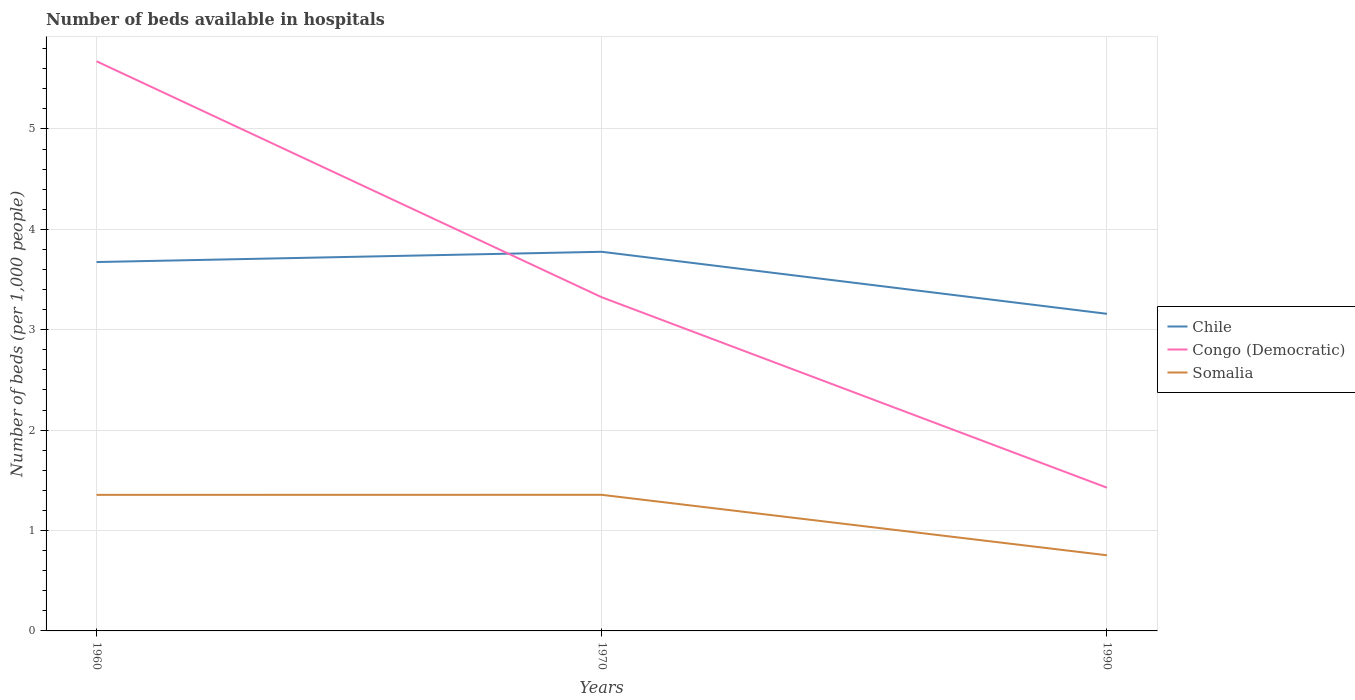How many different coloured lines are there?
Offer a terse response. 3. Is the number of lines equal to the number of legend labels?
Your response must be concise. Yes. Across all years, what is the maximum number of beds in the hospiatls of in Somalia?
Offer a terse response. 0.75. What is the total number of beds in the hospiatls of in Somalia in the graph?
Provide a succinct answer. 0.6. What is the difference between the highest and the second highest number of beds in the hospiatls of in Congo (Democratic)?
Your answer should be very brief. 4.25. Is the number of beds in the hospiatls of in Somalia strictly greater than the number of beds in the hospiatls of in Congo (Democratic) over the years?
Offer a terse response. Yes. Does the graph contain grids?
Offer a terse response. Yes. How many legend labels are there?
Give a very brief answer. 3. What is the title of the graph?
Offer a terse response. Number of beds available in hospitals. Does "South Asia" appear as one of the legend labels in the graph?
Make the answer very short. No. What is the label or title of the X-axis?
Keep it short and to the point. Years. What is the label or title of the Y-axis?
Your answer should be compact. Number of beds (per 1,0 people). What is the Number of beds (per 1,000 people) of Chile in 1960?
Offer a terse response. 3.67. What is the Number of beds (per 1,000 people) of Congo (Democratic) in 1960?
Your answer should be compact. 5.67. What is the Number of beds (per 1,000 people) in Somalia in 1960?
Offer a terse response. 1.36. What is the Number of beds (per 1,000 people) in Chile in 1970?
Ensure brevity in your answer.  3.78. What is the Number of beds (per 1,000 people) of Congo (Democratic) in 1970?
Provide a short and direct response. 3.32. What is the Number of beds (per 1,000 people) of Somalia in 1970?
Your answer should be very brief. 1.36. What is the Number of beds (per 1,000 people) of Chile in 1990?
Your response must be concise. 3.16. What is the Number of beds (per 1,000 people) in Congo (Democratic) in 1990?
Your answer should be compact. 1.43. What is the Number of beds (per 1,000 people) in Somalia in 1990?
Ensure brevity in your answer.  0.75. Across all years, what is the maximum Number of beds (per 1,000 people) of Chile?
Give a very brief answer. 3.78. Across all years, what is the maximum Number of beds (per 1,000 people) in Congo (Democratic)?
Your answer should be compact. 5.67. Across all years, what is the maximum Number of beds (per 1,000 people) in Somalia?
Your response must be concise. 1.36. Across all years, what is the minimum Number of beds (per 1,000 people) in Chile?
Offer a very short reply. 3.16. Across all years, what is the minimum Number of beds (per 1,000 people) in Congo (Democratic)?
Your response must be concise. 1.43. Across all years, what is the minimum Number of beds (per 1,000 people) in Somalia?
Keep it short and to the point. 0.75. What is the total Number of beds (per 1,000 people) of Chile in the graph?
Your response must be concise. 10.61. What is the total Number of beds (per 1,000 people) in Congo (Democratic) in the graph?
Make the answer very short. 10.42. What is the total Number of beds (per 1,000 people) in Somalia in the graph?
Offer a very short reply. 3.46. What is the difference between the Number of beds (per 1,000 people) in Chile in 1960 and that in 1970?
Provide a short and direct response. -0.1. What is the difference between the Number of beds (per 1,000 people) in Congo (Democratic) in 1960 and that in 1970?
Make the answer very short. 2.35. What is the difference between the Number of beds (per 1,000 people) in Somalia in 1960 and that in 1970?
Your answer should be compact. -0. What is the difference between the Number of beds (per 1,000 people) of Chile in 1960 and that in 1990?
Your response must be concise. 0.52. What is the difference between the Number of beds (per 1,000 people) in Congo (Democratic) in 1960 and that in 1990?
Provide a short and direct response. 4.25. What is the difference between the Number of beds (per 1,000 people) of Somalia in 1960 and that in 1990?
Your response must be concise. 0.6. What is the difference between the Number of beds (per 1,000 people) in Chile in 1970 and that in 1990?
Provide a short and direct response. 0.62. What is the difference between the Number of beds (per 1,000 people) of Congo (Democratic) in 1970 and that in 1990?
Provide a succinct answer. 1.9. What is the difference between the Number of beds (per 1,000 people) in Somalia in 1970 and that in 1990?
Provide a short and direct response. 0.6. What is the difference between the Number of beds (per 1,000 people) in Chile in 1960 and the Number of beds (per 1,000 people) in Congo (Democratic) in 1970?
Provide a succinct answer. 0.35. What is the difference between the Number of beds (per 1,000 people) of Chile in 1960 and the Number of beds (per 1,000 people) of Somalia in 1970?
Keep it short and to the point. 2.32. What is the difference between the Number of beds (per 1,000 people) of Congo (Democratic) in 1960 and the Number of beds (per 1,000 people) of Somalia in 1970?
Offer a terse response. 4.32. What is the difference between the Number of beds (per 1,000 people) of Chile in 1960 and the Number of beds (per 1,000 people) of Congo (Democratic) in 1990?
Keep it short and to the point. 2.25. What is the difference between the Number of beds (per 1,000 people) of Chile in 1960 and the Number of beds (per 1,000 people) of Somalia in 1990?
Give a very brief answer. 2.92. What is the difference between the Number of beds (per 1,000 people) in Congo (Democratic) in 1960 and the Number of beds (per 1,000 people) in Somalia in 1990?
Keep it short and to the point. 4.92. What is the difference between the Number of beds (per 1,000 people) in Chile in 1970 and the Number of beds (per 1,000 people) in Congo (Democratic) in 1990?
Provide a short and direct response. 2.35. What is the difference between the Number of beds (per 1,000 people) of Chile in 1970 and the Number of beds (per 1,000 people) of Somalia in 1990?
Offer a very short reply. 3.02. What is the difference between the Number of beds (per 1,000 people) of Congo (Democratic) in 1970 and the Number of beds (per 1,000 people) of Somalia in 1990?
Provide a short and direct response. 2.57. What is the average Number of beds (per 1,000 people) of Chile per year?
Make the answer very short. 3.54. What is the average Number of beds (per 1,000 people) in Congo (Democratic) per year?
Ensure brevity in your answer.  3.47. What is the average Number of beds (per 1,000 people) in Somalia per year?
Provide a short and direct response. 1.15. In the year 1960, what is the difference between the Number of beds (per 1,000 people) in Chile and Number of beds (per 1,000 people) in Congo (Democratic)?
Give a very brief answer. -2. In the year 1960, what is the difference between the Number of beds (per 1,000 people) of Chile and Number of beds (per 1,000 people) of Somalia?
Provide a short and direct response. 2.32. In the year 1960, what is the difference between the Number of beds (per 1,000 people) in Congo (Democratic) and Number of beds (per 1,000 people) in Somalia?
Your answer should be compact. 4.32. In the year 1970, what is the difference between the Number of beds (per 1,000 people) of Chile and Number of beds (per 1,000 people) of Congo (Democratic)?
Your answer should be compact. 0.45. In the year 1970, what is the difference between the Number of beds (per 1,000 people) of Chile and Number of beds (per 1,000 people) of Somalia?
Your answer should be compact. 2.42. In the year 1970, what is the difference between the Number of beds (per 1,000 people) in Congo (Democratic) and Number of beds (per 1,000 people) in Somalia?
Keep it short and to the point. 1.97. In the year 1990, what is the difference between the Number of beds (per 1,000 people) in Chile and Number of beds (per 1,000 people) in Congo (Democratic)?
Keep it short and to the point. 1.73. In the year 1990, what is the difference between the Number of beds (per 1,000 people) of Chile and Number of beds (per 1,000 people) of Somalia?
Make the answer very short. 2.41. In the year 1990, what is the difference between the Number of beds (per 1,000 people) of Congo (Democratic) and Number of beds (per 1,000 people) of Somalia?
Offer a terse response. 0.67. What is the ratio of the Number of beds (per 1,000 people) of Congo (Democratic) in 1960 to that in 1970?
Provide a succinct answer. 1.71. What is the ratio of the Number of beds (per 1,000 people) in Somalia in 1960 to that in 1970?
Your answer should be compact. 1. What is the ratio of the Number of beds (per 1,000 people) in Chile in 1960 to that in 1990?
Ensure brevity in your answer.  1.16. What is the ratio of the Number of beds (per 1,000 people) in Congo (Democratic) in 1960 to that in 1990?
Keep it short and to the point. 3.98. What is the ratio of the Number of beds (per 1,000 people) in Somalia in 1960 to that in 1990?
Your answer should be compact. 1.8. What is the ratio of the Number of beds (per 1,000 people) of Chile in 1970 to that in 1990?
Keep it short and to the point. 1.2. What is the ratio of the Number of beds (per 1,000 people) of Congo (Democratic) in 1970 to that in 1990?
Give a very brief answer. 2.33. What is the ratio of the Number of beds (per 1,000 people) in Somalia in 1970 to that in 1990?
Your answer should be compact. 1.8. What is the difference between the highest and the second highest Number of beds (per 1,000 people) in Chile?
Give a very brief answer. 0.1. What is the difference between the highest and the second highest Number of beds (per 1,000 people) in Congo (Democratic)?
Provide a succinct answer. 2.35. What is the difference between the highest and the lowest Number of beds (per 1,000 people) of Chile?
Give a very brief answer. 0.62. What is the difference between the highest and the lowest Number of beds (per 1,000 people) of Congo (Democratic)?
Your answer should be very brief. 4.25. What is the difference between the highest and the lowest Number of beds (per 1,000 people) in Somalia?
Make the answer very short. 0.6. 